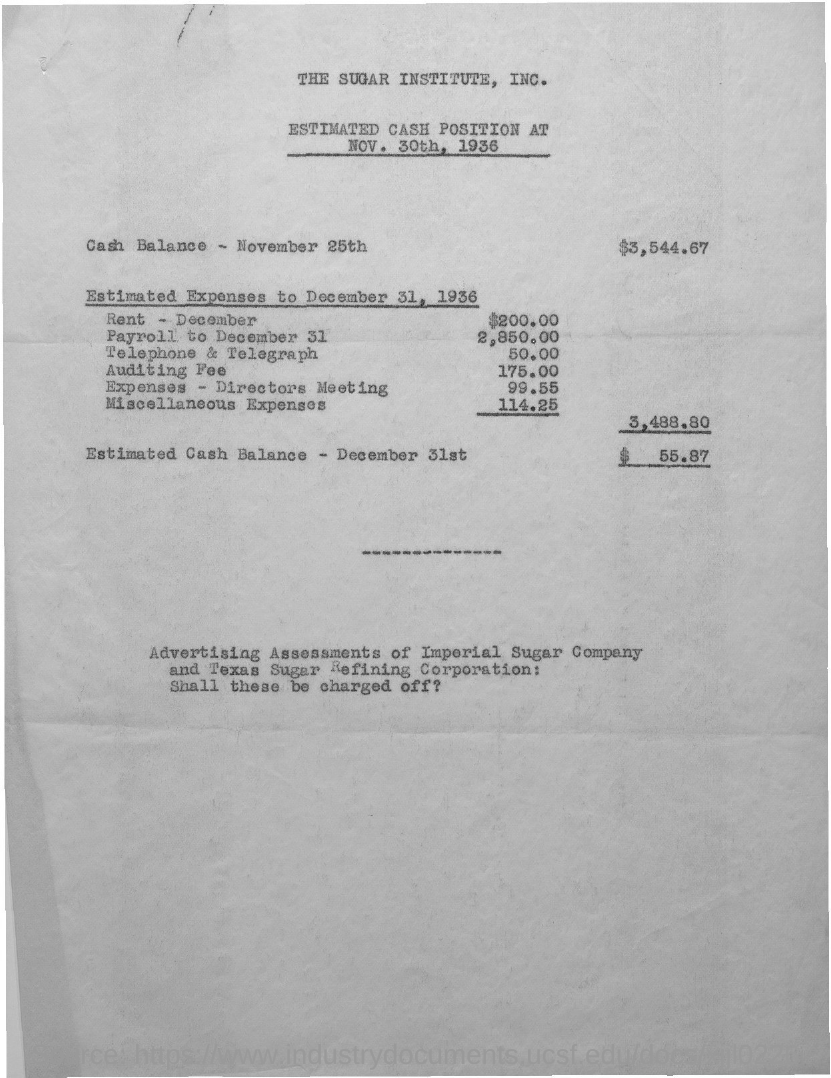What is the cash balance on november 25th?
Your response must be concise. $3,544.67. What is the estimated cash balance on december 31st?
Provide a succinct answer. $55.87. 